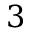<formula> <loc_0><loc_0><loc_500><loc_500>3</formula> 